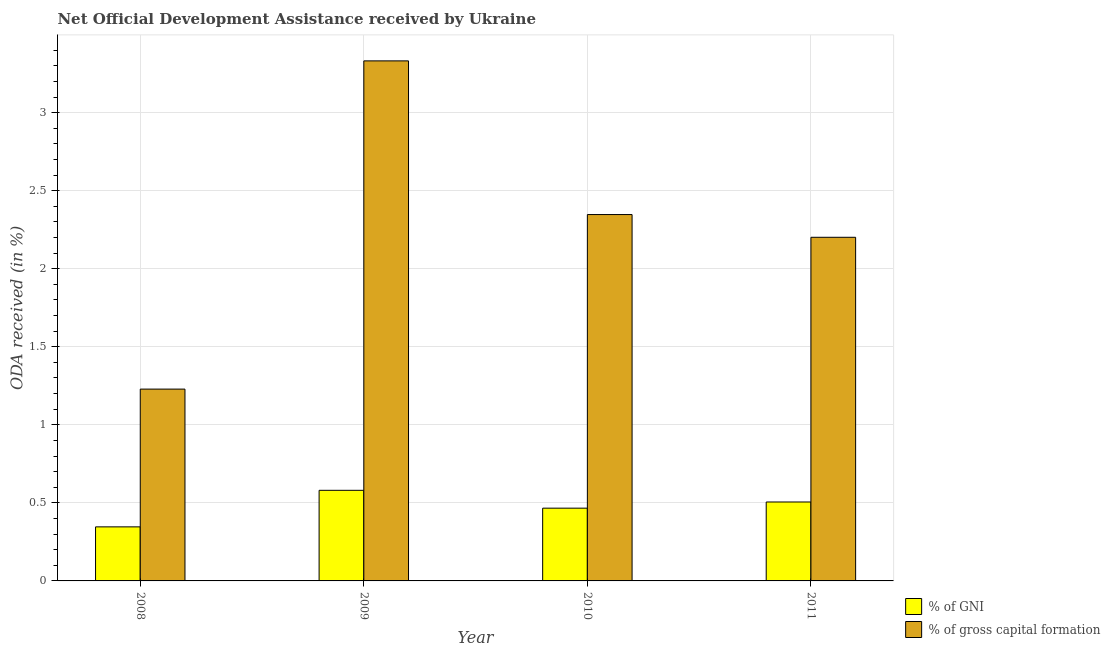How many different coloured bars are there?
Keep it short and to the point. 2. Are the number of bars on each tick of the X-axis equal?
Provide a succinct answer. Yes. How many bars are there on the 2nd tick from the left?
Your answer should be compact. 2. What is the oda received as percentage of gni in 2011?
Offer a terse response. 0.51. Across all years, what is the maximum oda received as percentage of gni?
Ensure brevity in your answer.  0.58. Across all years, what is the minimum oda received as percentage of gross capital formation?
Keep it short and to the point. 1.23. In which year was the oda received as percentage of gni maximum?
Your answer should be very brief. 2009. In which year was the oda received as percentage of gni minimum?
Offer a very short reply. 2008. What is the total oda received as percentage of gni in the graph?
Offer a very short reply. 1.9. What is the difference between the oda received as percentage of gross capital formation in 2009 and that in 2010?
Make the answer very short. 0.98. What is the difference between the oda received as percentage of gross capital formation in 2009 and the oda received as percentage of gni in 2008?
Give a very brief answer. 2.1. What is the average oda received as percentage of gross capital formation per year?
Make the answer very short. 2.28. In how many years, is the oda received as percentage of gross capital formation greater than 1 %?
Offer a terse response. 4. What is the ratio of the oda received as percentage of gross capital formation in 2008 to that in 2011?
Keep it short and to the point. 0.56. Is the oda received as percentage of gni in 2009 less than that in 2011?
Ensure brevity in your answer.  No. What is the difference between the highest and the second highest oda received as percentage of gni?
Offer a terse response. 0.07. What is the difference between the highest and the lowest oda received as percentage of gni?
Offer a terse response. 0.23. Is the sum of the oda received as percentage of gross capital formation in 2009 and 2010 greater than the maximum oda received as percentage of gni across all years?
Your answer should be compact. Yes. What does the 2nd bar from the left in 2010 represents?
Offer a very short reply. % of gross capital formation. What does the 2nd bar from the right in 2008 represents?
Offer a very short reply. % of GNI. How many bars are there?
Keep it short and to the point. 8. What is the difference between two consecutive major ticks on the Y-axis?
Offer a terse response. 0.5. Does the graph contain any zero values?
Provide a short and direct response. No. Where does the legend appear in the graph?
Your response must be concise. Bottom right. How many legend labels are there?
Give a very brief answer. 2. How are the legend labels stacked?
Offer a terse response. Vertical. What is the title of the graph?
Provide a succinct answer. Net Official Development Assistance received by Ukraine. What is the label or title of the Y-axis?
Your answer should be very brief. ODA received (in %). What is the ODA received (in %) in % of GNI in 2008?
Offer a terse response. 0.35. What is the ODA received (in %) of % of gross capital formation in 2008?
Your answer should be compact. 1.23. What is the ODA received (in %) in % of GNI in 2009?
Your answer should be compact. 0.58. What is the ODA received (in %) in % of gross capital formation in 2009?
Give a very brief answer. 3.33. What is the ODA received (in %) in % of GNI in 2010?
Provide a succinct answer. 0.47. What is the ODA received (in %) in % of gross capital formation in 2010?
Make the answer very short. 2.35. What is the ODA received (in %) in % of GNI in 2011?
Offer a terse response. 0.51. What is the ODA received (in %) in % of gross capital formation in 2011?
Your answer should be very brief. 2.2. Across all years, what is the maximum ODA received (in %) in % of GNI?
Ensure brevity in your answer.  0.58. Across all years, what is the maximum ODA received (in %) in % of gross capital formation?
Make the answer very short. 3.33. Across all years, what is the minimum ODA received (in %) in % of GNI?
Provide a succinct answer. 0.35. Across all years, what is the minimum ODA received (in %) of % of gross capital formation?
Keep it short and to the point. 1.23. What is the total ODA received (in %) of % of GNI in the graph?
Offer a terse response. 1.9. What is the total ODA received (in %) of % of gross capital formation in the graph?
Provide a short and direct response. 9.11. What is the difference between the ODA received (in %) in % of GNI in 2008 and that in 2009?
Your answer should be compact. -0.23. What is the difference between the ODA received (in %) of % of gross capital formation in 2008 and that in 2009?
Provide a succinct answer. -2.1. What is the difference between the ODA received (in %) in % of GNI in 2008 and that in 2010?
Give a very brief answer. -0.12. What is the difference between the ODA received (in %) in % of gross capital formation in 2008 and that in 2010?
Offer a very short reply. -1.12. What is the difference between the ODA received (in %) in % of GNI in 2008 and that in 2011?
Make the answer very short. -0.16. What is the difference between the ODA received (in %) in % of gross capital formation in 2008 and that in 2011?
Offer a terse response. -0.97. What is the difference between the ODA received (in %) of % of GNI in 2009 and that in 2010?
Your answer should be very brief. 0.11. What is the difference between the ODA received (in %) of % of gross capital formation in 2009 and that in 2010?
Keep it short and to the point. 0.98. What is the difference between the ODA received (in %) in % of GNI in 2009 and that in 2011?
Provide a short and direct response. 0.07. What is the difference between the ODA received (in %) in % of gross capital formation in 2009 and that in 2011?
Ensure brevity in your answer.  1.13. What is the difference between the ODA received (in %) in % of GNI in 2010 and that in 2011?
Offer a very short reply. -0.04. What is the difference between the ODA received (in %) of % of gross capital formation in 2010 and that in 2011?
Your response must be concise. 0.15. What is the difference between the ODA received (in %) of % of GNI in 2008 and the ODA received (in %) of % of gross capital formation in 2009?
Your answer should be very brief. -2.99. What is the difference between the ODA received (in %) in % of GNI in 2008 and the ODA received (in %) in % of gross capital formation in 2010?
Provide a short and direct response. -2. What is the difference between the ODA received (in %) of % of GNI in 2008 and the ODA received (in %) of % of gross capital formation in 2011?
Your answer should be compact. -1.85. What is the difference between the ODA received (in %) in % of GNI in 2009 and the ODA received (in %) in % of gross capital formation in 2010?
Your answer should be very brief. -1.77. What is the difference between the ODA received (in %) in % of GNI in 2009 and the ODA received (in %) in % of gross capital formation in 2011?
Your answer should be very brief. -1.62. What is the difference between the ODA received (in %) of % of GNI in 2010 and the ODA received (in %) of % of gross capital formation in 2011?
Provide a succinct answer. -1.74. What is the average ODA received (in %) in % of GNI per year?
Offer a very short reply. 0.47. What is the average ODA received (in %) of % of gross capital formation per year?
Give a very brief answer. 2.28. In the year 2008, what is the difference between the ODA received (in %) of % of GNI and ODA received (in %) of % of gross capital formation?
Your response must be concise. -0.88. In the year 2009, what is the difference between the ODA received (in %) of % of GNI and ODA received (in %) of % of gross capital formation?
Your response must be concise. -2.75. In the year 2010, what is the difference between the ODA received (in %) of % of GNI and ODA received (in %) of % of gross capital formation?
Offer a very short reply. -1.88. In the year 2011, what is the difference between the ODA received (in %) of % of GNI and ODA received (in %) of % of gross capital formation?
Provide a succinct answer. -1.7. What is the ratio of the ODA received (in %) of % of GNI in 2008 to that in 2009?
Your response must be concise. 0.6. What is the ratio of the ODA received (in %) of % of gross capital formation in 2008 to that in 2009?
Ensure brevity in your answer.  0.37. What is the ratio of the ODA received (in %) of % of GNI in 2008 to that in 2010?
Ensure brevity in your answer.  0.74. What is the ratio of the ODA received (in %) of % of gross capital formation in 2008 to that in 2010?
Your answer should be very brief. 0.52. What is the ratio of the ODA received (in %) in % of GNI in 2008 to that in 2011?
Give a very brief answer. 0.68. What is the ratio of the ODA received (in %) in % of gross capital formation in 2008 to that in 2011?
Your answer should be very brief. 0.56. What is the ratio of the ODA received (in %) in % of GNI in 2009 to that in 2010?
Your response must be concise. 1.25. What is the ratio of the ODA received (in %) in % of gross capital formation in 2009 to that in 2010?
Your answer should be very brief. 1.42. What is the ratio of the ODA received (in %) of % of GNI in 2009 to that in 2011?
Make the answer very short. 1.15. What is the ratio of the ODA received (in %) in % of gross capital formation in 2009 to that in 2011?
Offer a terse response. 1.51. What is the ratio of the ODA received (in %) of % of GNI in 2010 to that in 2011?
Offer a terse response. 0.92. What is the ratio of the ODA received (in %) of % of gross capital formation in 2010 to that in 2011?
Keep it short and to the point. 1.07. What is the difference between the highest and the second highest ODA received (in %) in % of GNI?
Keep it short and to the point. 0.07. What is the difference between the highest and the second highest ODA received (in %) in % of gross capital formation?
Give a very brief answer. 0.98. What is the difference between the highest and the lowest ODA received (in %) of % of GNI?
Your answer should be very brief. 0.23. What is the difference between the highest and the lowest ODA received (in %) in % of gross capital formation?
Make the answer very short. 2.1. 